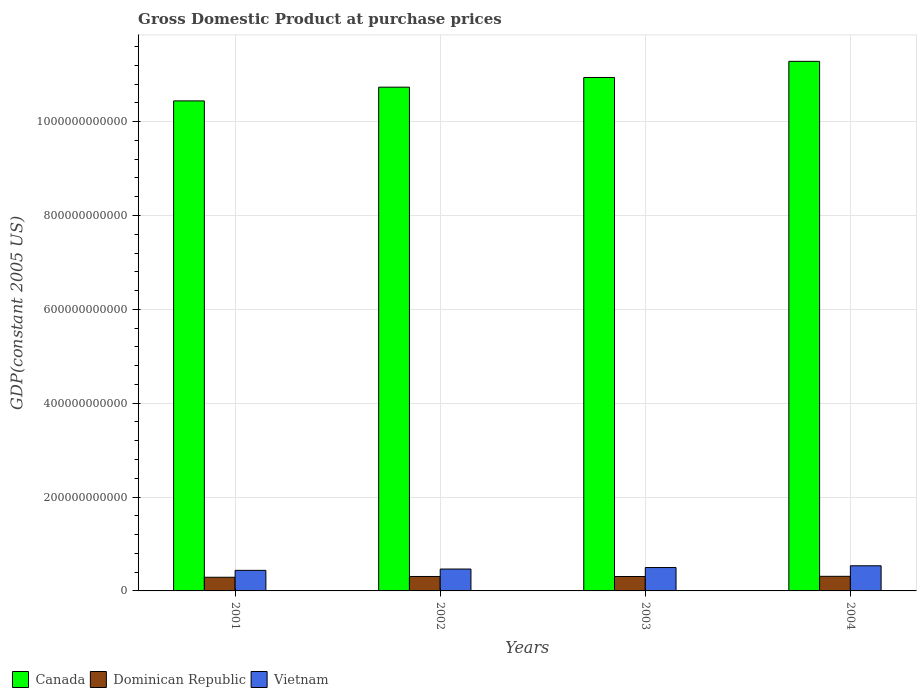How many different coloured bars are there?
Provide a succinct answer. 3. Are the number of bars per tick equal to the number of legend labels?
Your answer should be very brief. Yes. Are the number of bars on each tick of the X-axis equal?
Ensure brevity in your answer.  Yes. How many bars are there on the 2nd tick from the left?
Offer a terse response. 3. What is the GDP at purchase prices in Canada in 2001?
Your answer should be compact. 1.04e+12. Across all years, what is the maximum GDP at purchase prices in Dominican Republic?
Your answer should be compact. 3.11e+1. Across all years, what is the minimum GDP at purchase prices in Dominican Republic?
Offer a terse response. 2.91e+1. In which year was the GDP at purchase prices in Canada maximum?
Your answer should be very brief. 2004. What is the total GDP at purchase prices in Canada in the graph?
Offer a very short reply. 4.34e+12. What is the difference between the GDP at purchase prices in Vietnam in 2003 and that in 2004?
Provide a succinct answer. -3.76e+09. What is the difference between the GDP at purchase prices in Vietnam in 2001 and the GDP at purchase prices in Canada in 2004?
Provide a succinct answer. -1.08e+12. What is the average GDP at purchase prices in Canada per year?
Your response must be concise. 1.09e+12. In the year 2001, what is the difference between the GDP at purchase prices in Dominican Republic and GDP at purchase prices in Vietnam?
Keep it short and to the point. -1.47e+1. What is the ratio of the GDP at purchase prices in Canada in 2001 to that in 2004?
Give a very brief answer. 0.93. Is the GDP at purchase prices in Dominican Republic in 2001 less than that in 2004?
Provide a short and direct response. Yes. Is the difference between the GDP at purchase prices in Dominican Republic in 2001 and 2003 greater than the difference between the GDP at purchase prices in Vietnam in 2001 and 2003?
Provide a succinct answer. Yes. What is the difference between the highest and the second highest GDP at purchase prices in Dominican Republic?
Your answer should be compact. 3.25e+08. What is the difference between the highest and the lowest GDP at purchase prices in Vietnam?
Your answer should be very brief. 9.74e+09. In how many years, is the GDP at purchase prices in Vietnam greater than the average GDP at purchase prices in Vietnam taken over all years?
Ensure brevity in your answer.  2. Is the sum of the GDP at purchase prices in Vietnam in 2001 and 2002 greater than the maximum GDP at purchase prices in Canada across all years?
Offer a very short reply. No. What does the 2nd bar from the left in 2001 represents?
Offer a terse response. Dominican Republic. What does the 2nd bar from the right in 2003 represents?
Provide a succinct answer. Dominican Republic. How many bars are there?
Keep it short and to the point. 12. How many years are there in the graph?
Make the answer very short. 4. What is the difference between two consecutive major ticks on the Y-axis?
Ensure brevity in your answer.  2.00e+11. Does the graph contain any zero values?
Provide a short and direct response. No. How are the legend labels stacked?
Offer a terse response. Horizontal. What is the title of the graph?
Offer a very short reply. Gross Domestic Product at purchase prices. What is the label or title of the Y-axis?
Give a very brief answer. GDP(constant 2005 US). What is the GDP(constant 2005 US) in Canada in 2001?
Provide a short and direct response. 1.04e+12. What is the GDP(constant 2005 US) in Dominican Republic in 2001?
Your answer should be compact. 2.91e+1. What is the GDP(constant 2005 US) of Vietnam in 2001?
Offer a very short reply. 4.38e+1. What is the GDP(constant 2005 US) in Canada in 2002?
Your answer should be very brief. 1.07e+12. What is the GDP(constant 2005 US) in Dominican Republic in 2002?
Give a very brief answer. 3.08e+1. What is the GDP(constant 2005 US) of Vietnam in 2002?
Ensure brevity in your answer.  4.66e+1. What is the GDP(constant 2005 US) of Canada in 2003?
Your response must be concise. 1.09e+12. What is the GDP(constant 2005 US) in Dominican Republic in 2003?
Offer a terse response. 3.07e+1. What is the GDP(constant 2005 US) of Vietnam in 2003?
Your response must be concise. 4.98e+1. What is the GDP(constant 2005 US) in Canada in 2004?
Provide a short and direct response. 1.13e+12. What is the GDP(constant 2005 US) of Dominican Republic in 2004?
Keep it short and to the point. 3.11e+1. What is the GDP(constant 2005 US) in Vietnam in 2004?
Your answer should be very brief. 5.36e+1. Across all years, what is the maximum GDP(constant 2005 US) of Canada?
Offer a terse response. 1.13e+12. Across all years, what is the maximum GDP(constant 2005 US) in Dominican Republic?
Offer a very short reply. 3.11e+1. Across all years, what is the maximum GDP(constant 2005 US) of Vietnam?
Keep it short and to the point. 5.36e+1. Across all years, what is the minimum GDP(constant 2005 US) in Canada?
Your answer should be compact. 1.04e+12. Across all years, what is the minimum GDP(constant 2005 US) in Dominican Republic?
Offer a terse response. 2.91e+1. Across all years, what is the minimum GDP(constant 2005 US) of Vietnam?
Your answer should be very brief. 4.38e+1. What is the total GDP(constant 2005 US) in Canada in the graph?
Your response must be concise. 4.34e+12. What is the total GDP(constant 2005 US) in Dominican Republic in the graph?
Offer a very short reply. 1.22e+11. What is the total GDP(constant 2005 US) of Vietnam in the graph?
Give a very brief answer. 1.94e+11. What is the difference between the GDP(constant 2005 US) of Canada in 2001 and that in 2002?
Offer a terse response. -2.93e+1. What is the difference between the GDP(constant 2005 US) of Dominican Republic in 2001 and that in 2002?
Your response must be concise. -1.69e+09. What is the difference between the GDP(constant 2005 US) in Vietnam in 2001 and that in 2002?
Offer a very short reply. -2.77e+09. What is the difference between the GDP(constant 2005 US) in Canada in 2001 and that in 2003?
Give a very brief answer. -4.99e+1. What is the difference between the GDP(constant 2005 US) of Dominican Republic in 2001 and that in 2003?
Your answer should be compact. -1.61e+09. What is the difference between the GDP(constant 2005 US) of Vietnam in 2001 and that in 2003?
Provide a succinct answer. -5.99e+09. What is the difference between the GDP(constant 2005 US) of Canada in 2001 and that in 2004?
Keep it short and to the point. -8.43e+1. What is the difference between the GDP(constant 2005 US) in Dominican Republic in 2001 and that in 2004?
Your answer should be very brief. -2.01e+09. What is the difference between the GDP(constant 2005 US) in Vietnam in 2001 and that in 2004?
Make the answer very short. -9.74e+09. What is the difference between the GDP(constant 2005 US) in Canada in 2002 and that in 2003?
Offer a terse response. -2.07e+1. What is the difference between the GDP(constant 2005 US) in Dominican Republic in 2002 and that in 2003?
Make the answer very short. 7.80e+07. What is the difference between the GDP(constant 2005 US) of Vietnam in 2002 and that in 2003?
Make the answer very short. -3.22e+09. What is the difference between the GDP(constant 2005 US) of Canada in 2002 and that in 2004?
Your response must be concise. -5.50e+1. What is the difference between the GDP(constant 2005 US) of Dominican Republic in 2002 and that in 2004?
Keep it short and to the point. -3.25e+08. What is the difference between the GDP(constant 2005 US) of Vietnam in 2002 and that in 2004?
Give a very brief answer. -6.97e+09. What is the difference between the GDP(constant 2005 US) in Canada in 2003 and that in 2004?
Your answer should be compact. -3.43e+1. What is the difference between the GDP(constant 2005 US) in Dominican Republic in 2003 and that in 2004?
Your answer should be compact. -4.03e+08. What is the difference between the GDP(constant 2005 US) of Vietnam in 2003 and that in 2004?
Keep it short and to the point. -3.76e+09. What is the difference between the GDP(constant 2005 US) in Canada in 2001 and the GDP(constant 2005 US) in Dominican Republic in 2002?
Give a very brief answer. 1.01e+12. What is the difference between the GDP(constant 2005 US) in Canada in 2001 and the GDP(constant 2005 US) in Vietnam in 2002?
Keep it short and to the point. 9.98e+11. What is the difference between the GDP(constant 2005 US) in Dominican Republic in 2001 and the GDP(constant 2005 US) in Vietnam in 2002?
Provide a succinct answer. -1.75e+1. What is the difference between the GDP(constant 2005 US) of Canada in 2001 and the GDP(constant 2005 US) of Dominican Republic in 2003?
Ensure brevity in your answer.  1.01e+12. What is the difference between the GDP(constant 2005 US) in Canada in 2001 and the GDP(constant 2005 US) in Vietnam in 2003?
Your answer should be compact. 9.94e+11. What is the difference between the GDP(constant 2005 US) of Dominican Republic in 2001 and the GDP(constant 2005 US) of Vietnam in 2003?
Your response must be concise. -2.07e+1. What is the difference between the GDP(constant 2005 US) of Canada in 2001 and the GDP(constant 2005 US) of Dominican Republic in 2004?
Keep it short and to the point. 1.01e+12. What is the difference between the GDP(constant 2005 US) in Canada in 2001 and the GDP(constant 2005 US) in Vietnam in 2004?
Your answer should be compact. 9.91e+11. What is the difference between the GDP(constant 2005 US) of Dominican Republic in 2001 and the GDP(constant 2005 US) of Vietnam in 2004?
Offer a terse response. -2.45e+1. What is the difference between the GDP(constant 2005 US) of Canada in 2002 and the GDP(constant 2005 US) of Dominican Republic in 2003?
Keep it short and to the point. 1.04e+12. What is the difference between the GDP(constant 2005 US) in Canada in 2002 and the GDP(constant 2005 US) in Vietnam in 2003?
Your answer should be very brief. 1.02e+12. What is the difference between the GDP(constant 2005 US) in Dominican Republic in 2002 and the GDP(constant 2005 US) in Vietnam in 2003?
Make the answer very short. -1.90e+1. What is the difference between the GDP(constant 2005 US) in Canada in 2002 and the GDP(constant 2005 US) in Dominican Republic in 2004?
Your response must be concise. 1.04e+12. What is the difference between the GDP(constant 2005 US) of Canada in 2002 and the GDP(constant 2005 US) of Vietnam in 2004?
Offer a very short reply. 1.02e+12. What is the difference between the GDP(constant 2005 US) in Dominican Republic in 2002 and the GDP(constant 2005 US) in Vietnam in 2004?
Ensure brevity in your answer.  -2.28e+1. What is the difference between the GDP(constant 2005 US) of Canada in 2003 and the GDP(constant 2005 US) of Dominican Republic in 2004?
Provide a short and direct response. 1.06e+12. What is the difference between the GDP(constant 2005 US) in Canada in 2003 and the GDP(constant 2005 US) in Vietnam in 2004?
Your answer should be very brief. 1.04e+12. What is the difference between the GDP(constant 2005 US) of Dominican Republic in 2003 and the GDP(constant 2005 US) of Vietnam in 2004?
Provide a short and direct response. -2.29e+1. What is the average GDP(constant 2005 US) in Canada per year?
Ensure brevity in your answer.  1.09e+12. What is the average GDP(constant 2005 US) in Dominican Republic per year?
Your answer should be compact. 3.04e+1. What is the average GDP(constant 2005 US) of Vietnam per year?
Your answer should be very brief. 4.85e+1. In the year 2001, what is the difference between the GDP(constant 2005 US) of Canada and GDP(constant 2005 US) of Dominican Republic?
Your answer should be compact. 1.02e+12. In the year 2001, what is the difference between the GDP(constant 2005 US) in Canada and GDP(constant 2005 US) in Vietnam?
Your answer should be compact. 1.00e+12. In the year 2001, what is the difference between the GDP(constant 2005 US) in Dominican Republic and GDP(constant 2005 US) in Vietnam?
Your answer should be very brief. -1.47e+1. In the year 2002, what is the difference between the GDP(constant 2005 US) in Canada and GDP(constant 2005 US) in Dominican Republic?
Your answer should be compact. 1.04e+12. In the year 2002, what is the difference between the GDP(constant 2005 US) in Canada and GDP(constant 2005 US) in Vietnam?
Keep it short and to the point. 1.03e+12. In the year 2002, what is the difference between the GDP(constant 2005 US) in Dominican Republic and GDP(constant 2005 US) in Vietnam?
Ensure brevity in your answer.  -1.58e+1. In the year 2003, what is the difference between the GDP(constant 2005 US) in Canada and GDP(constant 2005 US) in Dominican Republic?
Offer a terse response. 1.06e+12. In the year 2003, what is the difference between the GDP(constant 2005 US) of Canada and GDP(constant 2005 US) of Vietnam?
Your answer should be very brief. 1.04e+12. In the year 2003, what is the difference between the GDP(constant 2005 US) in Dominican Republic and GDP(constant 2005 US) in Vietnam?
Ensure brevity in your answer.  -1.91e+1. In the year 2004, what is the difference between the GDP(constant 2005 US) of Canada and GDP(constant 2005 US) of Dominican Republic?
Provide a succinct answer. 1.10e+12. In the year 2004, what is the difference between the GDP(constant 2005 US) of Canada and GDP(constant 2005 US) of Vietnam?
Make the answer very short. 1.07e+12. In the year 2004, what is the difference between the GDP(constant 2005 US) in Dominican Republic and GDP(constant 2005 US) in Vietnam?
Keep it short and to the point. -2.25e+1. What is the ratio of the GDP(constant 2005 US) of Canada in 2001 to that in 2002?
Keep it short and to the point. 0.97. What is the ratio of the GDP(constant 2005 US) of Dominican Republic in 2001 to that in 2002?
Offer a very short reply. 0.95. What is the ratio of the GDP(constant 2005 US) in Vietnam in 2001 to that in 2002?
Give a very brief answer. 0.94. What is the ratio of the GDP(constant 2005 US) in Canada in 2001 to that in 2003?
Your response must be concise. 0.95. What is the ratio of the GDP(constant 2005 US) in Dominican Republic in 2001 to that in 2003?
Provide a short and direct response. 0.95. What is the ratio of the GDP(constant 2005 US) of Vietnam in 2001 to that in 2003?
Ensure brevity in your answer.  0.88. What is the ratio of the GDP(constant 2005 US) of Canada in 2001 to that in 2004?
Provide a short and direct response. 0.93. What is the ratio of the GDP(constant 2005 US) of Dominican Republic in 2001 to that in 2004?
Ensure brevity in your answer.  0.94. What is the ratio of the GDP(constant 2005 US) in Vietnam in 2001 to that in 2004?
Offer a very short reply. 0.82. What is the ratio of the GDP(constant 2005 US) in Canada in 2002 to that in 2003?
Ensure brevity in your answer.  0.98. What is the ratio of the GDP(constant 2005 US) in Vietnam in 2002 to that in 2003?
Your answer should be compact. 0.94. What is the ratio of the GDP(constant 2005 US) in Canada in 2002 to that in 2004?
Your answer should be compact. 0.95. What is the ratio of the GDP(constant 2005 US) in Vietnam in 2002 to that in 2004?
Your answer should be compact. 0.87. What is the ratio of the GDP(constant 2005 US) in Canada in 2003 to that in 2004?
Your answer should be compact. 0.97. What is the ratio of the GDP(constant 2005 US) in Dominican Republic in 2003 to that in 2004?
Offer a very short reply. 0.99. What is the ratio of the GDP(constant 2005 US) in Vietnam in 2003 to that in 2004?
Make the answer very short. 0.93. What is the difference between the highest and the second highest GDP(constant 2005 US) in Canada?
Offer a very short reply. 3.43e+1. What is the difference between the highest and the second highest GDP(constant 2005 US) of Dominican Republic?
Your response must be concise. 3.25e+08. What is the difference between the highest and the second highest GDP(constant 2005 US) of Vietnam?
Your response must be concise. 3.76e+09. What is the difference between the highest and the lowest GDP(constant 2005 US) of Canada?
Your answer should be compact. 8.43e+1. What is the difference between the highest and the lowest GDP(constant 2005 US) in Dominican Republic?
Offer a terse response. 2.01e+09. What is the difference between the highest and the lowest GDP(constant 2005 US) in Vietnam?
Provide a short and direct response. 9.74e+09. 